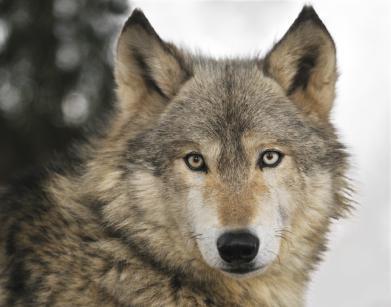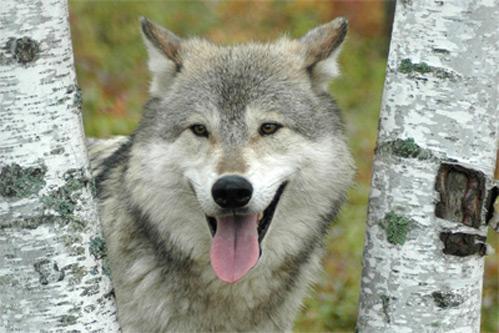The first image is the image on the left, the second image is the image on the right. For the images shown, is this caption "The left image shows a camera-gazing wolf with a bit of snow on its fur, and the right image contains two wolves in the foreground." true? Answer yes or no. No. The first image is the image on the left, the second image is the image on the right. For the images displayed, is the sentence "You can see two or more wolves side by side in one of the pictures." factually correct? Answer yes or no. No. 